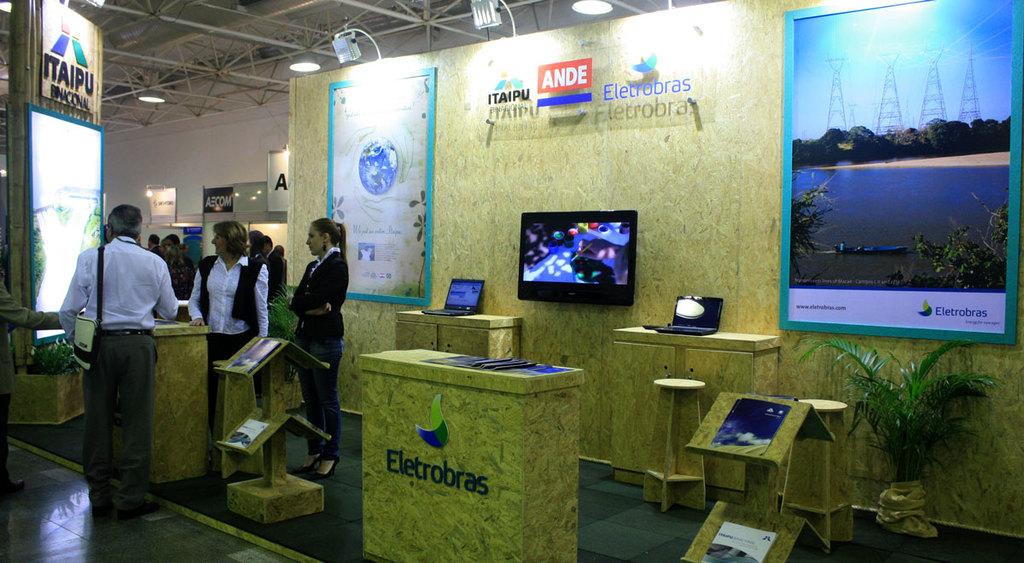What does the podium say?
Provide a short and direct response. Eletrobras. What is written in white letters with a red background?
Make the answer very short. Ande. 